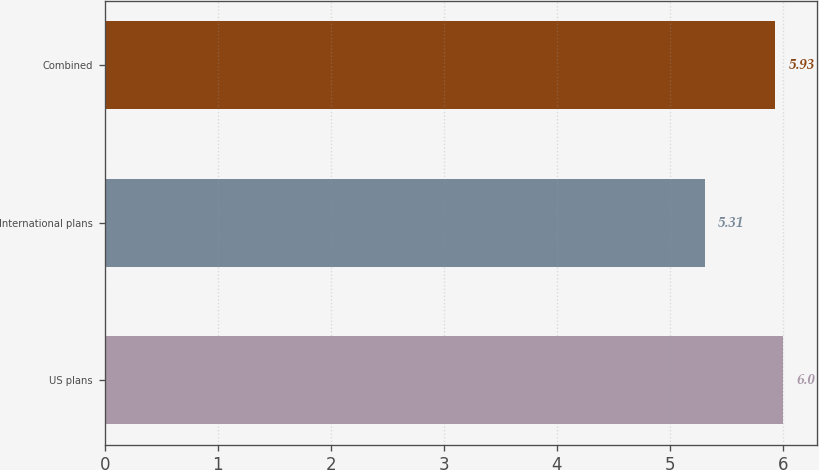<chart> <loc_0><loc_0><loc_500><loc_500><bar_chart><fcel>US plans<fcel>International plans<fcel>Combined<nl><fcel>6<fcel>5.31<fcel>5.93<nl></chart> 